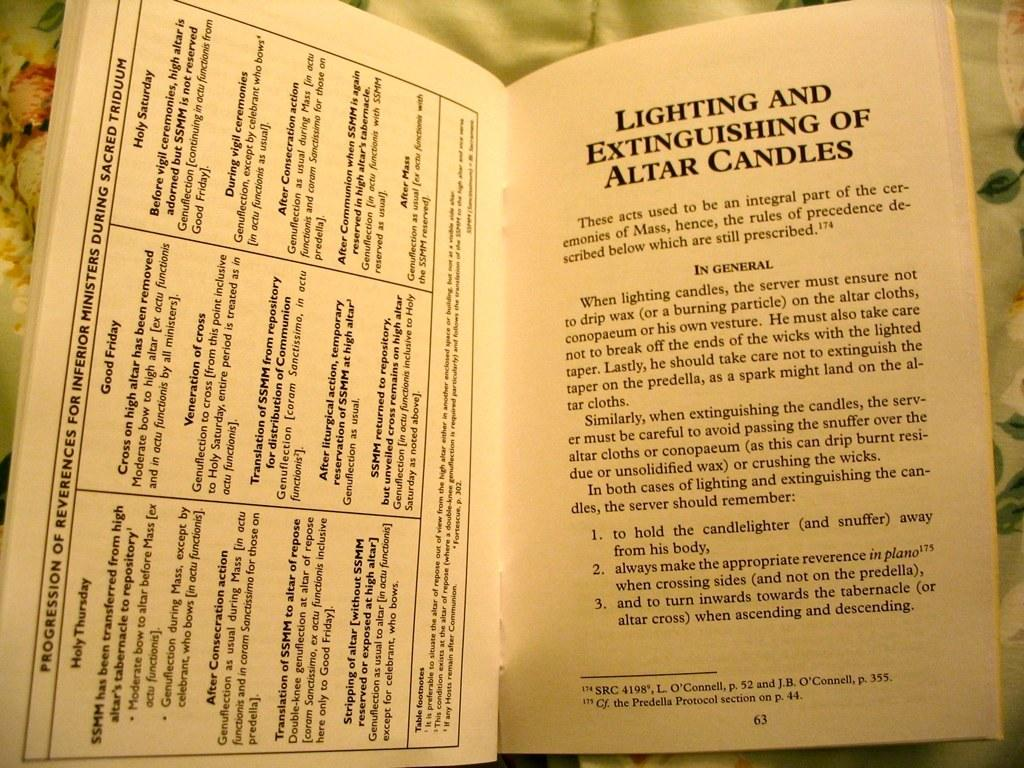Provide a one-sentence caption for the provided image. A copy of a book called "Lighting and Extinguishing of Altar Candles". 